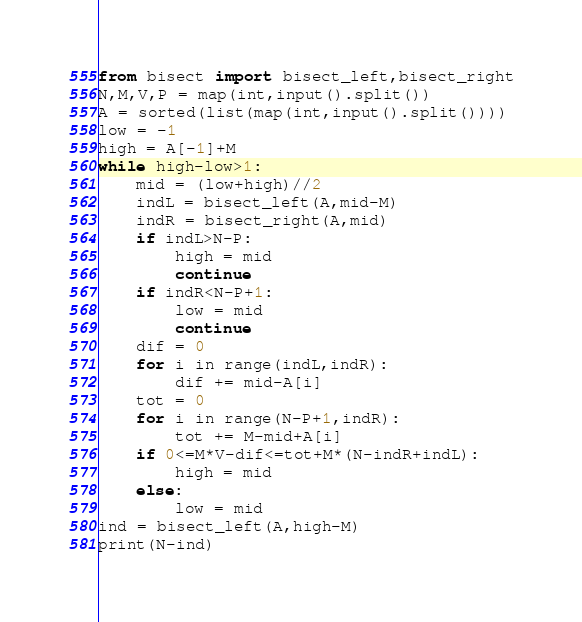Convert code to text. <code><loc_0><loc_0><loc_500><loc_500><_Python_>from bisect import bisect_left,bisect_right
N,M,V,P = map(int,input().split())
A = sorted(list(map(int,input().split())))
low = -1
high = A[-1]+M
while high-low>1:
    mid = (low+high)//2
    indL = bisect_left(A,mid-M)
    indR = bisect_right(A,mid)
    if indL>N-P:
        high = mid
        continue
    if indR<N-P+1:
        low = mid
        continue
    dif = 0
    for i in range(indL,indR):
        dif += mid-A[i]
    tot = 0
    for i in range(N-P+1,indR):
        tot += M-mid+A[i]
    if 0<=M*V-dif<=tot+M*(N-indR+indL):
        high = mid
    else:
        low = mid
ind = bisect_left(A,high-M)
print(N-ind)</code> 